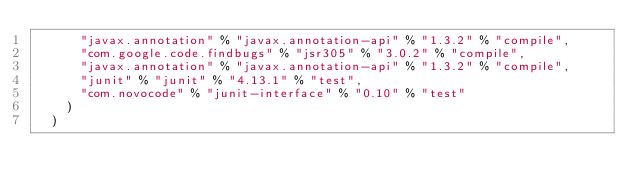Convert code to text. <code><loc_0><loc_0><loc_500><loc_500><_Scala_>      "javax.annotation" % "javax.annotation-api" % "1.3.2" % "compile",
      "com.google.code.findbugs" % "jsr305" % "3.0.2" % "compile",
      "javax.annotation" % "javax.annotation-api" % "1.3.2" % "compile",
      "junit" % "junit" % "4.13.1" % "test",
      "com.novocode" % "junit-interface" % "0.10" % "test"
    )
  )
</code> 